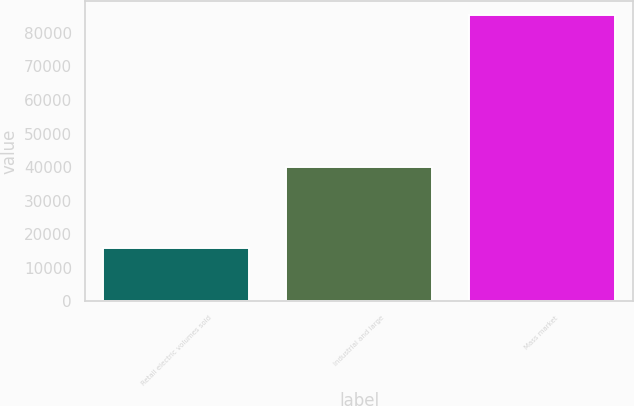<chart> <loc_0><loc_0><loc_500><loc_500><bar_chart><fcel>Retail electric volumes sold<fcel>Industrial and large<fcel>Mass market<nl><fcel>15993<fcel>40081<fcel>85191<nl></chart> 